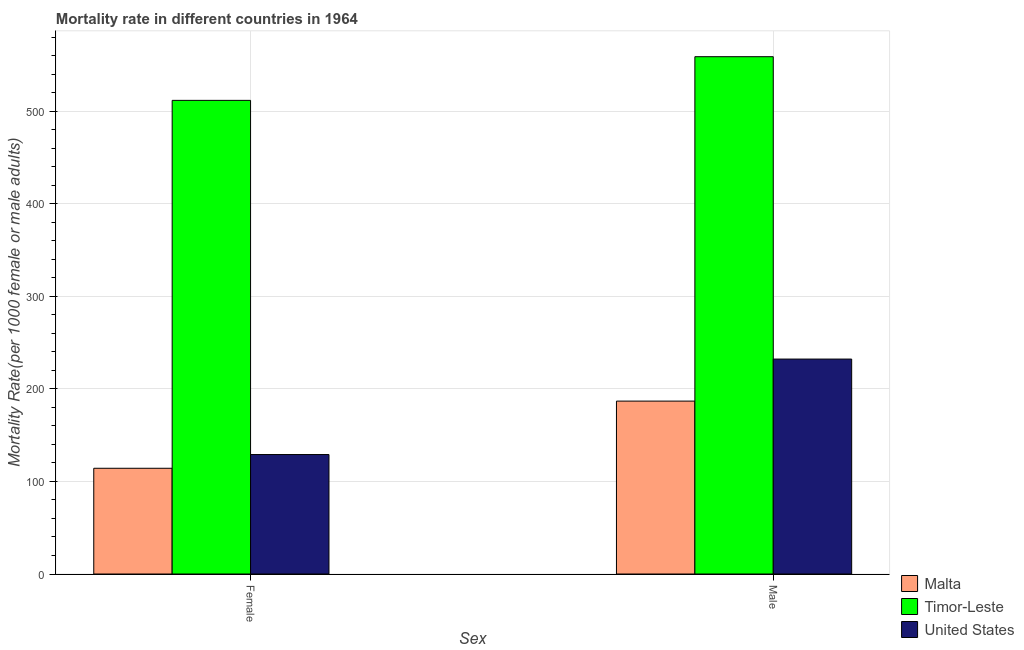Are the number of bars per tick equal to the number of legend labels?
Offer a very short reply. Yes. What is the label of the 2nd group of bars from the left?
Ensure brevity in your answer.  Male. What is the male mortality rate in Malta?
Keep it short and to the point. 186.84. Across all countries, what is the maximum male mortality rate?
Offer a very short reply. 559.01. Across all countries, what is the minimum male mortality rate?
Keep it short and to the point. 186.84. In which country was the female mortality rate maximum?
Your answer should be compact. Timor-Leste. In which country was the female mortality rate minimum?
Give a very brief answer. Malta. What is the total male mortality rate in the graph?
Your answer should be very brief. 978.11. What is the difference between the male mortality rate in Timor-Leste and that in United States?
Make the answer very short. 326.75. What is the difference between the female mortality rate in United States and the male mortality rate in Timor-Leste?
Your answer should be compact. -429.92. What is the average female mortality rate per country?
Ensure brevity in your answer.  251.72. What is the difference between the female mortality rate and male mortality rate in Malta?
Make the answer very short. -72.59. In how many countries, is the female mortality rate greater than 460 ?
Your answer should be compact. 1. What is the ratio of the male mortality rate in United States to that in Malta?
Keep it short and to the point. 1.24. What does the 2nd bar from the left in Female represents?
Offer a very short reply. Timor-Leste. What does the 3rd bar from the right in Female represents?
Provide a short and direct response. Malta. Are all the bars in the graph horizontal?
Ensure brevity in your answer.  No. Are the values on the major ticks of Y-axis written in scientific E-notation?
Provide a short and direct response. No. Does the graph contain any zero values?
Give a very brief answer. No. Where does the legend appear in the graph?
Provide a succinct answer. Bottom right. What is the title of the graph?
Provide a succinct answer. Mortality rate in different countries in 1964. Does "Mongolia" appear as one of the legend labels in the graph?
Ensure brevity in your answer.  No. What is the label or title of the X-axis?
Keep it short and to the point. Sex. What is the label or title of the Y-axis?
Give a very brief answer. Mortality Rate(per 1000 female or male adults). What is the Mortality Rate(per 1000 female or male adults) of Malta in Female?
Your answer should be very brief. 114.25. What is the Mortality Rate(per 1000 female or male adults) of Timor-Leste in Female?
Provide a short and direct response. 511.82. What is the Mortality Rate(per 1000 female or male adults) of United States in Female?
Provide a short and direct response. 129.09. What is the Mortality Rate(per 1000 female or male adults) in Malta in Male?
Provide a short and direct response. 186.84. What is the Mortality Rate(per 1000 female or male adults) of Timor-Leste in Male?
Offer a terse response. 559.01. What is the Mortality Rate(per 1000 female or male adults) of United States in Male?
Ensure brevity in your answer.  232.26. Across all Sex, what is the maximum Mortality Rate(per 1000 female or male adults) in Malta?
Your answer should be compact. 186.84. Across all Sex, what is the maximum Mortality Rate(per 1000 female or male adults) in Timor-Leste?
Keep it short and to the point. 559.01. Across all Sex, what is the maximum Mortality Rate(per 1000 female or male adults) in United States?
Your answer should be compact. 232.26. Across all Sex, what is the minimum Mortality Rate(per 1000 female or male adults) of Malta?
Offer a terse response. 114.25. Across all Sex, what is the minimum Mortality Rate(per 1000 female or male adults) of Timor-Leste?
Provide a short and direct response. 511.82. Across all Sex, what is the minimum Mortality Rate(per 1000 female or male adults) in United States?
Make the answer very short. 129.09. What is the total Mortality Rate(per 1000 female or male adults) of Malta in the graph?
Give a very brief answer. 301.09. What is the total Mortality Rate(per 1000 female or male adults) of Timor-Leste in the graph?
Offer a very short reply. 1070.83. What is the total Mortality Rate(per 1000 female or male adults) of United States in the graph?
Offer a very short reply. 361.35. What is the difference between the Mortality Rate(per 1000 female or male adults) of Malta in Female and that in Male?
Your answer should be compact. -72.59. What is the difference between the Mortality Rate(per 1000 female or male adults) in Timor-Leste in Female and that in Male?
Provide a succinct answer. -47.19. What is the difference between the Mortality Rate(per 1000 female or male adults) in United States in Female and that in Male?
Give a very brief answer. -103.17. What is the difference between the Mortality Rate(per 1000 female or male adults) in Malta in Female and the Mortality Rate(per 1000 female or male adults) in Timor-Leste in Male?
Provide a succinct answer. -444.76. What is the difference between the Mortality Rate(per 1000 female or male adults) in Malta in Female and the Mortality Rate(per 1000 female or male adults) in United States in Male?
Your answer should be compact. -118.01. What is the difference between the Mortality Rate(per 1000 female or male adults) in Timor-Leste in Female and the Mortality Rate(per 1000 female or male adults) in United States in Male?
Offer a terse response. 279.56. What is the average Mortality Rate(per 1000 female or male adults) in Malta per Sex?
Offer a very short reply. 150.55. What is the average Mortality Rate(per 1000 female or male adults) of Timor-Leste per Sex?
Ensure brevity in your answer.  535.41. What is the average Mortality Rate(per 1000 female or male adults) in United States per Sex?
Keep it short and to the point. 180.67. What is the difference between the Mortality Rate(per 1000 female or male adults) in Malta and Mortality Rate(per 1000 female or male adults) in Timor-Leste in Female?
Make the answer very short. -397.57. What is the difference between the Mortality Rate(per 1000 female or male adults) in Malta and Mortality Rate(per 1000 female or male adults) in United States in Female?
Your response must be concise. -14.84. What is the difference between the Mortality Rate(per 1000 female or male adults) of Timor-Leste and Mortality Rate(per 1000 female or male adults) of United States in Female?
Your response must be concise. 382.73. What is the difference between the Mortality Rate(per 1000 female or male adults) in Malta and Mortality Rate(per 1000 female or male adults) in Timor-Leste in Male?
Give a very brief answer. -372.16. What is the difference between the Mortality Rate(per 1000 female or male adults) in Malta and Mortality Rate(per 1000 female or male adults) in United States in Male?
Your response must be concise. -45.42. What is the difference between the Mortality Rate(per 1000 female or male adults) of Timor-Leste and Mortality Rate(per 1000 female or male adults) of United States in Male?
Make the answer very short. 326.75. What is the ratio of the Mortality Rate(per 1000 female or male adults) in Malta in Female to that in Male?
Provide a short and direct response. 0.61. What is the ratio of the Mortality Rate(per 1000 female or male adults) of Timor-Leste in Female to that in Male?
Provide a succinct answer. 0.92. What is the ratio of the Mortality Rate(per 1000 female or male adults) of United States in Female to that in Male?
Give a very brief answer. 0.56. What is the difference between the highest and the second highest Mortality Rate(per 1000 female or male adults) of Malta?
Your response must be concise. 72.59. What is the difference between the highest and the second highest Mortality Rate(per 1000 female or male adults) in Timor-Leste?
Your answer should be very brief. 47.19. What is the difference between the highest and the second highest Mortality Rate(per 1000 female or male adults) of United States?
Give a very brief answer. 103.17. What is the difference between the highest and the lowest Mortality Rate(per 1000 female or male adults) in Malta?
Your response must be concise. 72.59. What is the difference between the highest and the lowest Mortality Rate(per 1000 female or male adults) in Timor-Leste?
Your response must be concise. 47.19. What is the difference between the highest and the lowest Mortality Rate(per 1000 female or male adults) of United States?
Make the answer very short. 103.17. 